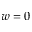Convert formula to latex. <formula><loc_0><loc_0><loc_500><loc_500>w = 0</formula> 